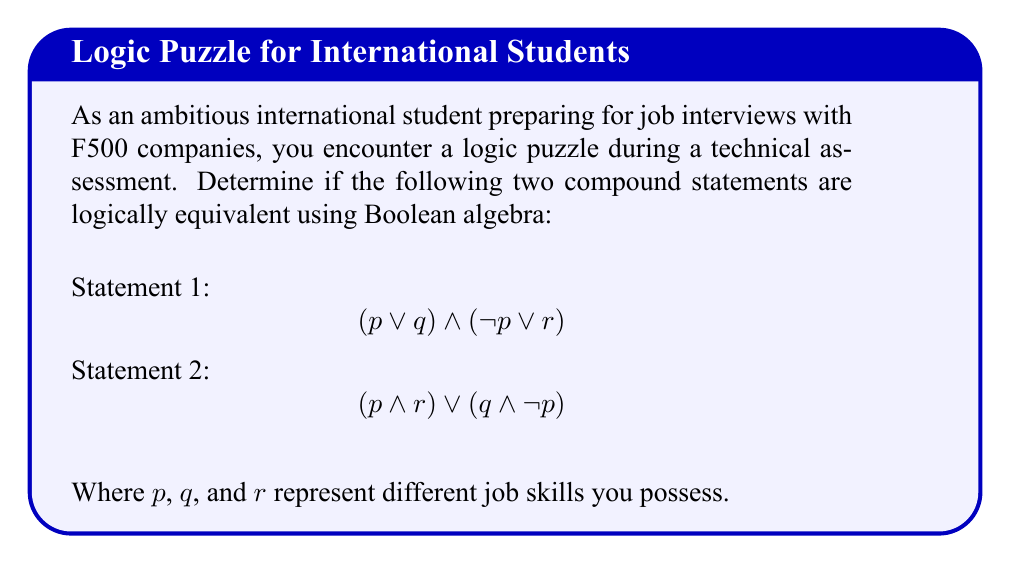Can you solve this math problem? To determine if the two statements are logically equivalent, we'll use Boolean algebra to simplify both statements and compare the results.

1. Simplify Statement 1:
   $$(p \lor q) \land (\lnot p \lor r)$$
   
   Apply the distributive law:
   $$p \land (\lnot p \lor r) \lor q \land (\lnot p \lor r)$$
   
   Simplify using the absorption law ($(p \land (\lnot p \lor r)) \equiv (p \land r)$):
   $$(p \land r) \lor (q \land \lnot p) \lor (q \land r)$$

2. Simplify Statement 2:
   $$(p \land r) \lor (q \land \lnot p)$$
   
   This statement is already in its simplest form.

3. Compare the simplified statements:
   Statement 1: $$(p \land r) \lor (q \land \lnot p) \lor (q \land r)$$
   Statement 2: $$(p \land r) \lor (q \land \lnot p)$$

   We can see that Statement 1 has an additional term $(q \land r)$ compared to Statement 2.

4. Conclusion:
   Since the simplified forms are not identical, the original statements are not logically equivalent.
Answer: Not logically equivalent 